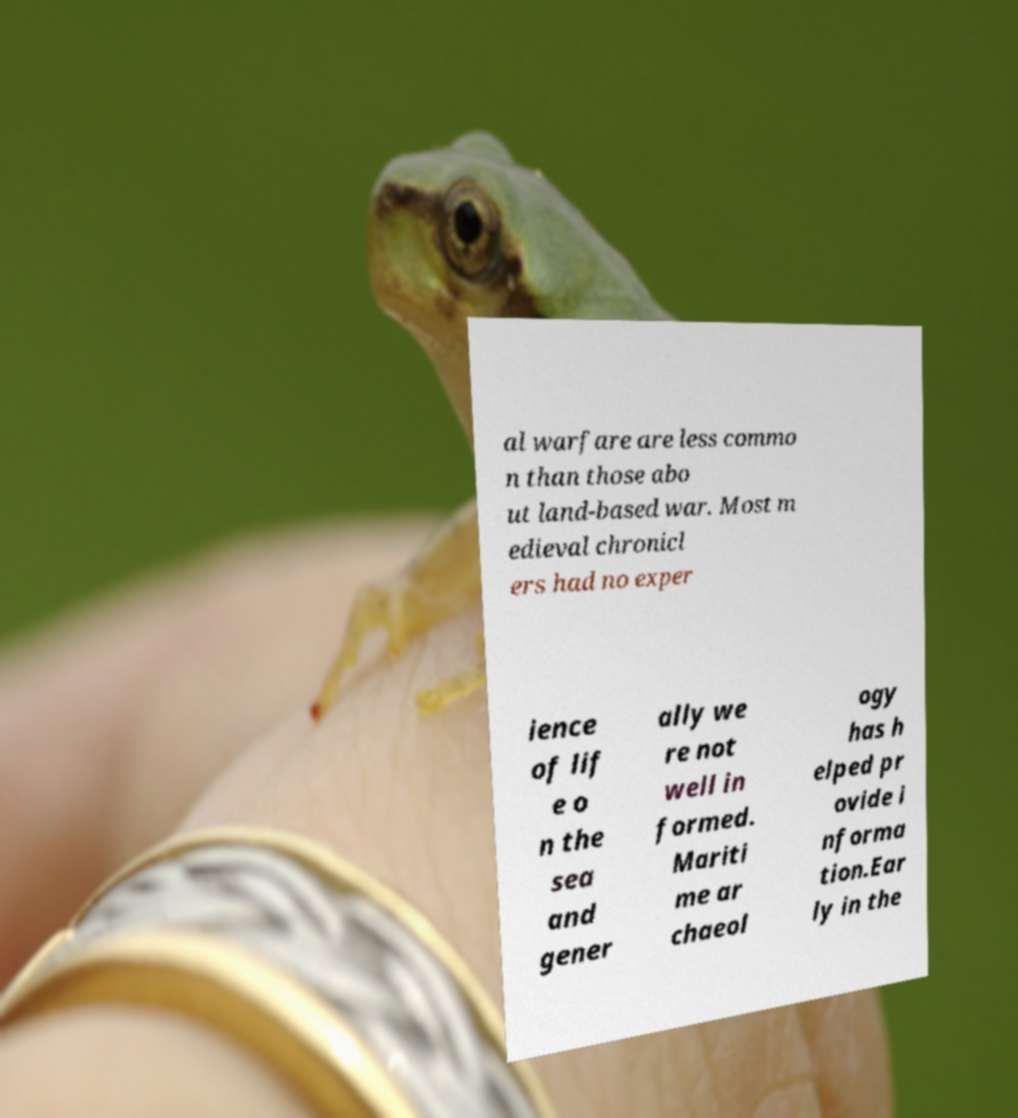For documentation purposes, I need the text within this image transcribed. Could you provide that? al warfare are less commo n than those abo ut land-based war. Most m edieval chronicl ers had no exper ience of lif e o n the sea and gener ally we re not well in formed. Mariti me ar chaeol ogy has h elped pr ovide i nforma tion.Ear ly in the 